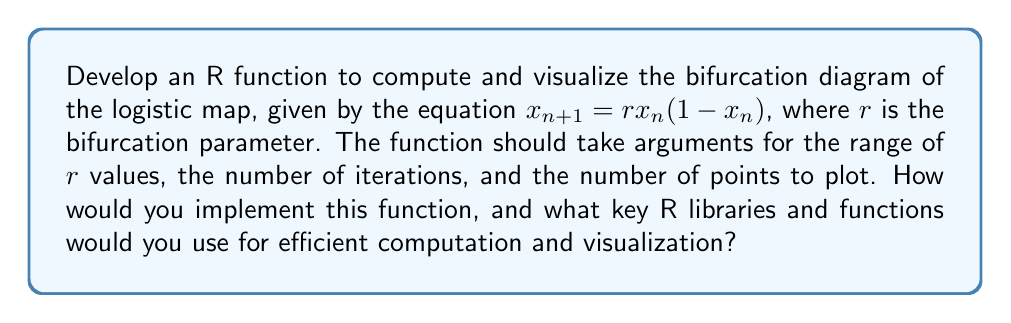What is the answer to this math problem? To develop an R function for computing and visualizing the bifurcation diagram of the logistic map, we can follow these steps:

1. Define the function with appropriate parameters:
   ```R
   logistic_bifurcation <- function(r_min, r_max, n_points, n_iterations, n_discard) {
     # Function body
   }
   ```

2. Generate a sequence of r values:
   ```R
   r_values <- seq(r_min, r_max, length.out = n_points)
   ```

3. Initialize a matrix to store the results:
   ```R
   results <- matrix(nrow = n_points, ncol = n_iterations - n_discard)
   ```

4. Implement the logistic map iteration:
   ```R
   for (i in 1:n_points) {
     x <- 0.5  # Initial condition
     r <- r_values[i]
     
     for (j in 1:n_iterations) {
       x <- r * x * (1 - x)
       if (j > n_discard) {
         results[i, j - n_discard] <- x
       }
     }
   }
   ```

5. Prepare the data for plotting:
   ```R
   plot_data <- data.frame(
     r = rep(r_values, each = n_iterations - n_discard),
     x = as.vector(results)
   )
   ```

6. Use ggplot2 for visualization:
   ```R
   library(ggplot2)
   
   ggplot(plot_data, aes(x = r, y = x)) +
     geom_point(size = 0.1, alpha = 0.1) +
     labs(title = "Bifurcation Diagram of the Logistic Map",
          x = "r", y = "x") +
     theme_minimal()
   ```

Key R libraries and functions for efficient computation and visualization:

1. Base R functions: `seq()`, `matrix()`, `rep()`, `as.vector()`
2. ggplot2: For creating the bifurcation diagram plot
3. data.frame: For organizing the data for plotting
4. Vectorization: Using matrix operations for efficiency

To further optimize the computation, you could consider using the `apply()` family of functions or packages like `purrr` for functional programming approaches.
Answer: Create function with nested loops for iteration, use matrix for storage, and visualize with ggplot2. 